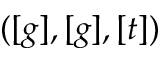<formula> <loc_0><loc_0><loc_500><loc_500>( [ g ] , [ g ] , [ t ] )</formula> 